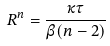<formula> <loc_0><loc_0><loc_500><loc_500>R ^ { n } = \frac { \kappa \tau } { \beta ( n - 2 ) }</formula> 